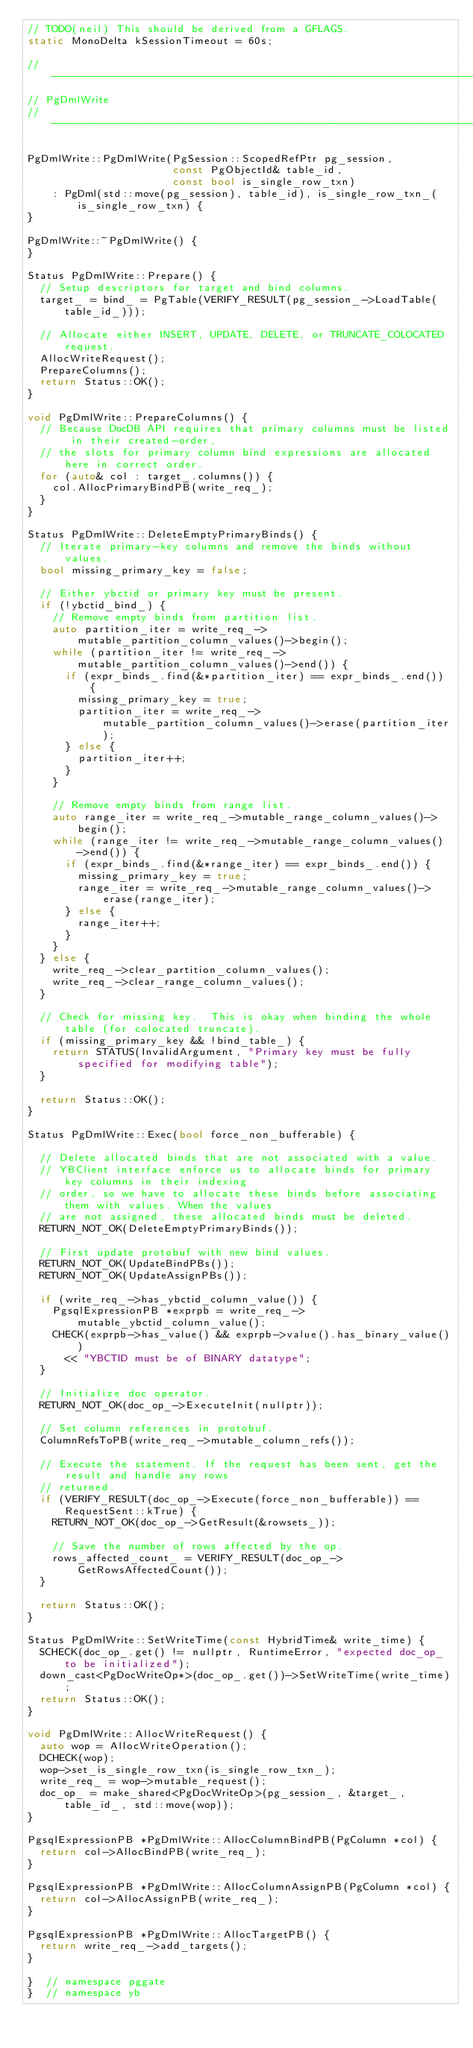<code> <loc_0><loc_0><loc_500><loc_500><_C++_>// TODO(neil) This should be derived from a GFLAGS.
static MonoDelta kSessionTimeout = 60s;

//--------------------------------------------------------------------------------------------------
// PgDmlWrite
//--------------------------------------------------------------------------------------------------

PgDmlWrite::PgDmlWrite(PgSession::ScopedRefPtr pg_session,
                       const PgObjectId& table_id,
                       const bool is_single_row_txn)
    : PgDml(std::move(pg_session), table_id), is_single_row_txn_(is_single_row_txn) {
}

PgDmlWrite::~PgDmlWrite() {
}

Status PgDmlWrite::Prepare() {
  // Setup descriptors for target and bind columns.
  target_ = bind_ = PgTable(VERIFY_RESULT(pg_session_->LoadTable(table_id_)));

  // Allocate either INSERT, UPDATE, DELETE, or TRUNCATE_COLOCATED request.
  AllocWriteRequest();
  PrepareColumns();
  return Status::OK();
}

void PgDmlWrite::PrepareColumns() {
  // Because DocDB API requires that primary columns must be listed in their created-order,
  // the slots for primary column bind expressions are allocated here in correct order.
  for (auto& col : target_.columns()) {
    col.AllocPrimaryBindPB(write_req_);
  }
}

Status PgDmlWrite::DeleteEmptyPrimaryBinds() {
  // Iterate primary-key columns and remove the binds without values.
  bool missing_primary_key = false;

  // Either ybctid or primary key must be present.
  if (!ybctid_bind_) {
    // Remove empty binds from partition list.
    auto partition_iter = write_req_->mutable_partition_column_values()->begin();
    while (partition_iter != write_req_->mutable_partition_column_values()->end()) {
      if (expr_binds_.find(&*partition_iter) == expr_binds_.end()) {
        missing_primary_key = true;
        partition_iter = write_req_->mutable_partition_column_values()->erase(partition_iter);
      } else {
        partition_iter++;
      }
    }

    // Remove empty binds from range list.
    auto range_iter = write_req_->mutable_range_column_values()->begin();
    while (range_iter != write_req_->mutable_range_column_values()->end()) {
      if (expr_binds_.find(&*range_iter) == expr_binds_.end()) {
        missing_primary_key = true;
        range_iter = write_req_->mutable_range_column_values()->erase(range_iter);
      } else {
        range_iter++;
      }
    }
  } else {
    write_req_->clear_partition_column_values();
    write_req_->clear_range_column_values();
  }

  // Check for missing key.  This is okay when binding the whole table (for colocated truncate).
  if (missing_primary_key && !bind_table_) {
    return STATUS(InvalidArgument, "Primary key must be fully specified for modifying table");
  }

  return Status::OK();
}

Status PgDmlWrite::Exec(bool force_non_bufferable) {

  // Delete allocated binds that are not associated with a value.
  // YBClient interface enforce us to allocate binds for primary key columns in their indexing
  // order, so we have to allocate these binds before associating them with values. When the values
  // are not assigned, these allocated binds must be deleted.
  RETURN_NOT_OK(DeleteEmptyPrimaryBinds());

  // First update protobuf with new bind values.
  RETURN_NOT_OK(UpdateBindPBs());
  RETURN_NOT_OK(UpdateAssignPBs());

  if (write_req_->has_ybctid_column_value()) {
    PgsqlExpressionPB *exprpb = write_req_->mutable_ybctid_column_value();
    CHECK(exprpb->has_value() && exprpb->value().has_binary_value())
      << "YBCTID must be of BINARY datatype";
  }

  // Initialize doc operator.
  RETURN_NOT_OK(doc_op_->ExecuteInit(nullptr));

  // Set column references in protobuf.
  ColumnRefsToPB(write_req_->mutable_column_refs());

  // Execute the statement. If the request has been sent, get the result and handle any rows
  // returned.
  if (VERIFY_RESULT(doc_op_->Execute(force_non_bufferable)) == RequestSent::kTrue) {
    RETURN_NOT_OK(doc_op_->GetResult(&rowsets_));

    // Save the number of rows affected by the op.
    rows_affected_count_ = VERIFY_RESULT(doc_op_->GetRowsAffectedCount());
  }

  return Status::OK();
}

Status PgDmlWrite::SetWriteTime(const HybridTime& write_time) {
  SCHECK(doc_op_.get() != nullptr, RuntimeError, "expected doc_op_ to be initialized");
  down_cast<PgDocWriteOp*>(doc_op_.get())->SetWriteTime(write_time);
  return Status::OK();
}

void PgDmlWrite::AllocWriteRequest() {
  auto wop = AllocWriteOperation();
  DCHECK(wop);
  wop->set_is_single_row_txn(is_single_row_txn_);
  write_req_ = wop->mutable_request();
  doc_op_ = make_shared<PgDocWriteOp>(pg_session_, &target_, table_id_, std::move(wop));
}

PgsqlExpressionPB *PgDmlWrite::AllocColumnBindPB(PgColumn *col) {
  return col->AllocBindPB(write_req_);
}

PgsqlExpressionPB *PgDmlWrite::AllocColumnAssignPB(PgColumn *col) {
  return col->AllocAssignPB(write_req_);
}

PgsqlExpressionPB *PgDmlWrite::AllocTargetPB() {
  return write_req_->add_targets();
}

}  // namespace pggate
}  // namespace yb
</code> 